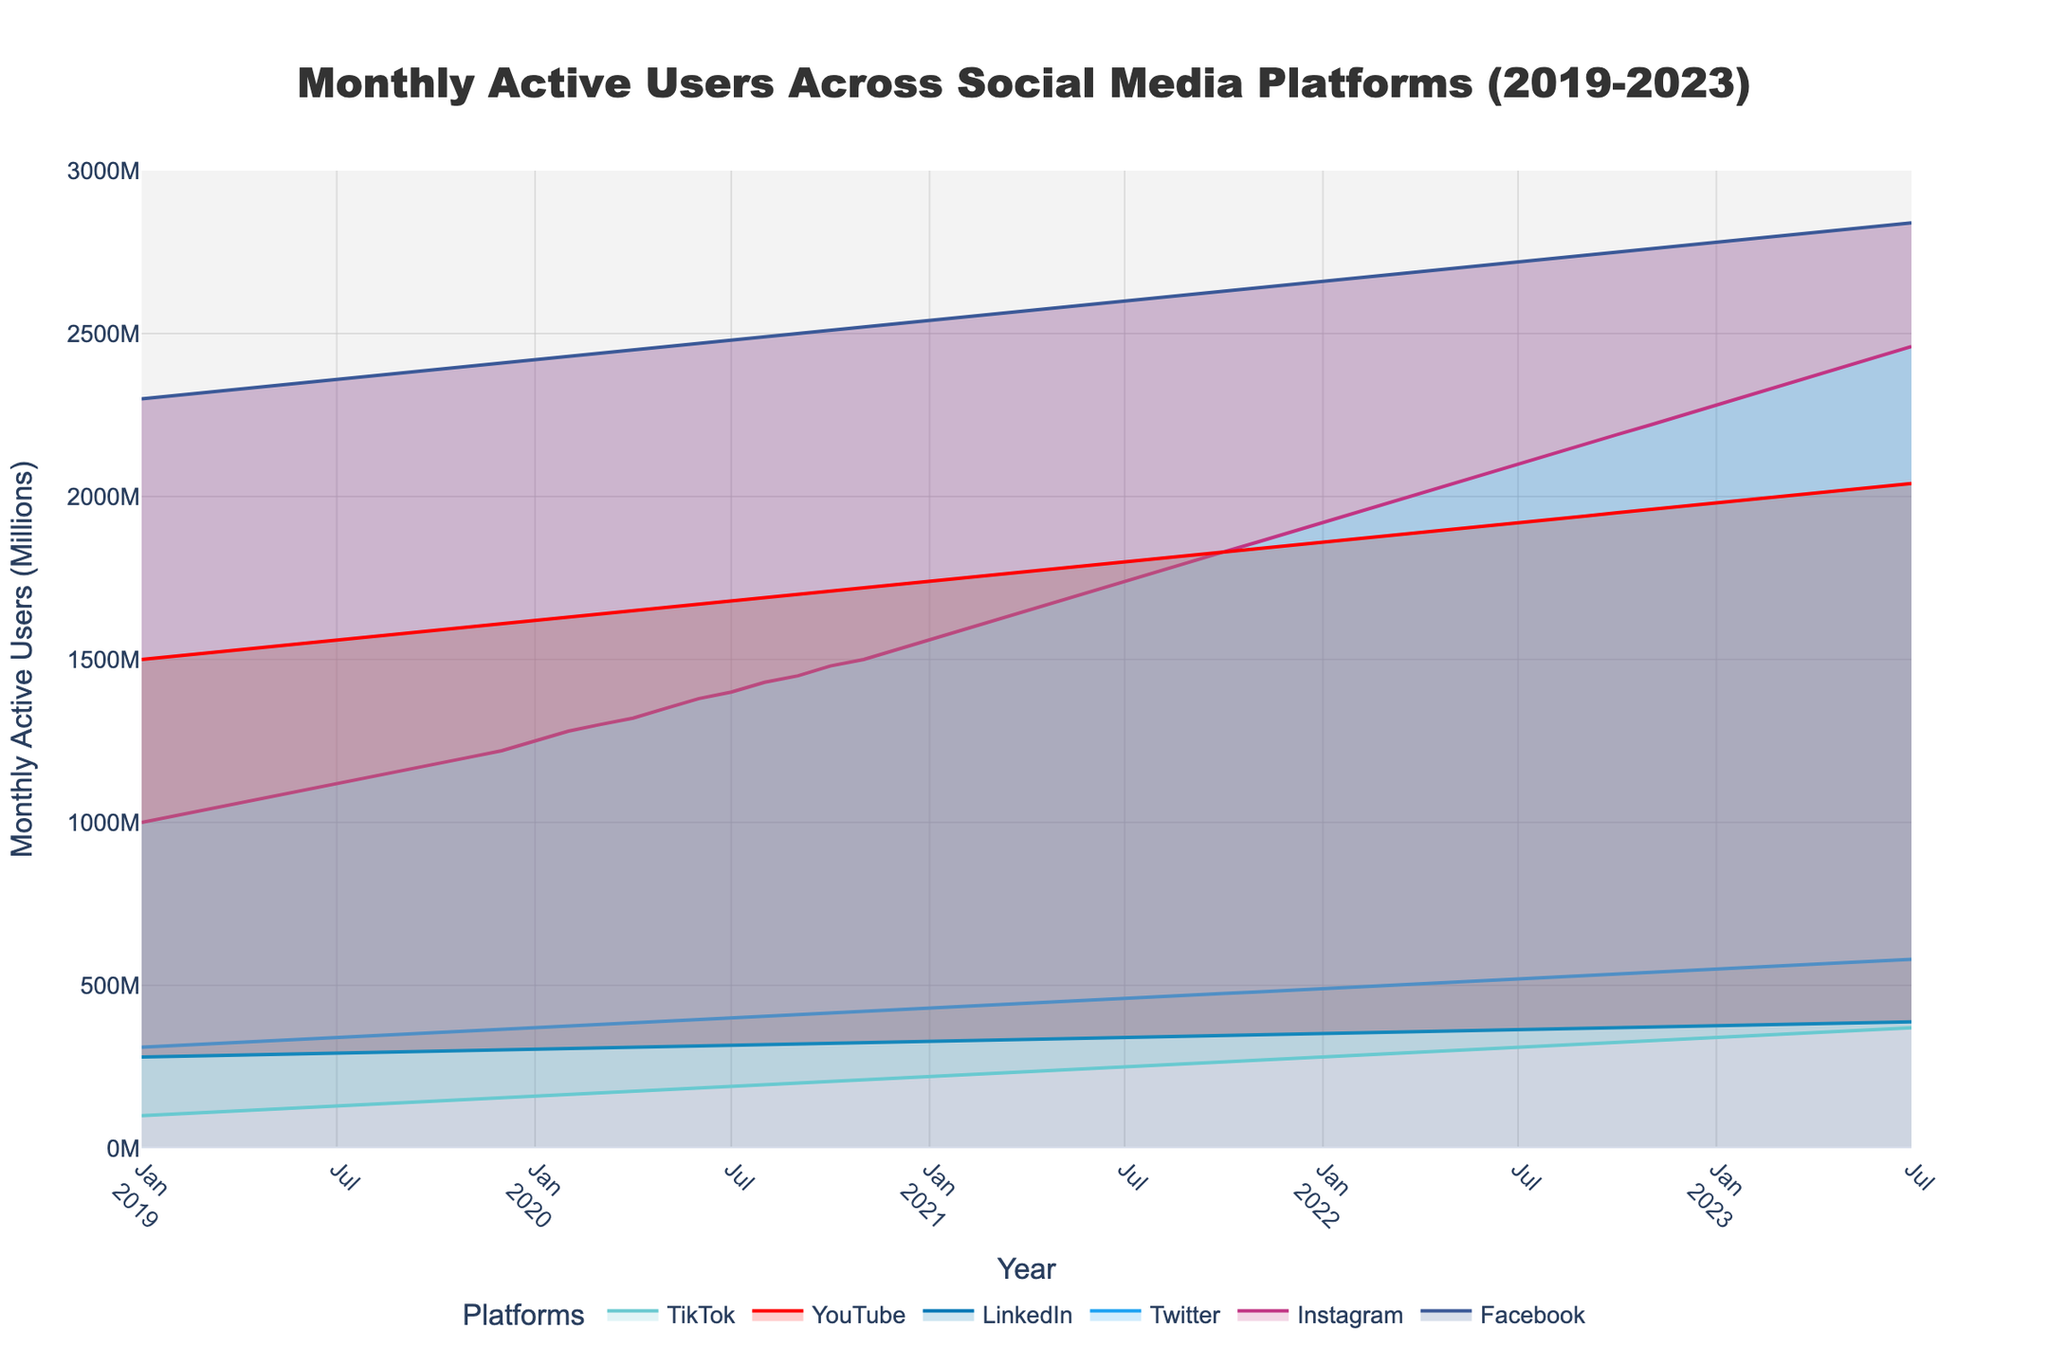What is the title of the area chart? The title is located at the top center of the chart, and it typically describes the subject of the visualization. In this case, the title is "Monthly Active Users Across Social Media Platforms (2019-2023)".
Answer: Monthly Active Users Across Social Media Platforms (2019-2023) How many platforms are compared in the chart? The number of platforms can be determined by counting the distinct colored areas or by looking at the legend, which lists each platform. There are six platforms listed: Facebook, Instagram, Twitter, LinkedIn, YouTube, and TikTok.
Answer: Six Which platform had the highest number of monthly active users in July 2020? In July 2020, we need to compare the height of the filled areas corresponding to each platform. The highest point represents the platform with the most users. Facebook has the highest number of users in July 2020.
Answer: Facebook Which platform showed the most consistent growth over the entire period from 2019 to 2023? To evaluate consistency, observe the smoothness and regularity of the lines. Consistent growth would show as a steady, upward-sloping line without significant fluctuations. TikTok shows the most consistent growth, with a smooth and steady increase.
Answer: TikTok What was the increase in monthly active users for Instagram from January 2019 to July 2023? First, find the values for Instagram in January 2019 and July 2023. In January 2019, Instagram had 1000 million users, and in July 2023, it had 2460 million users. The increase is 2460 - 1000 = 1460 million users.
Answer: 1460 million In which month of 2021 did LinkedIn reach 350 million users? Look along LinkedIn's line in 2021 and find the month where its value first hits 350 million. LinkedIn reached 350 million users in December 2021.
Answer: December 2021 By how many million users did YouTube's monthly active users increase from January 2019 to July 2023? Sum the number of users in January 2019 and July 2023 for YouTube. From the chart, YouTube had 1500 million users in January 2019 and 2040 million users in July 2023. The increase is 2040 - 1500 = 540 million users.
Answer: 540 million Which two platforms experienced the steepest growth between mid-2020 and the end of 2020? Compare the slopes of the lines for the platforms between mid-2020 and the end of 2020. The steepest slopes indicate the fastest growth rates. Instagram and TikTok experienced the steepest growth during this period.
Answer: Instagram and TikTok What was the approximate combined number of monthly active users for Twitter and LinkedIn in December 2022? Find the values for both Twitter and LinkedIn in December 2022 and sum them. For December 2022, Twitter had about 545 million users, and LinkedIn had about 374 million users. The combined total is 545 + 374 = 919 million users.
Answer: 919 million Did any platform experience a decline in monthly active users between 2019 and 2023? To determine this, examine each platform's line from 2019 to 2023 for any downward trends. All platforms show an overall increase in users throughout the period, with no declines.
Answer: No 